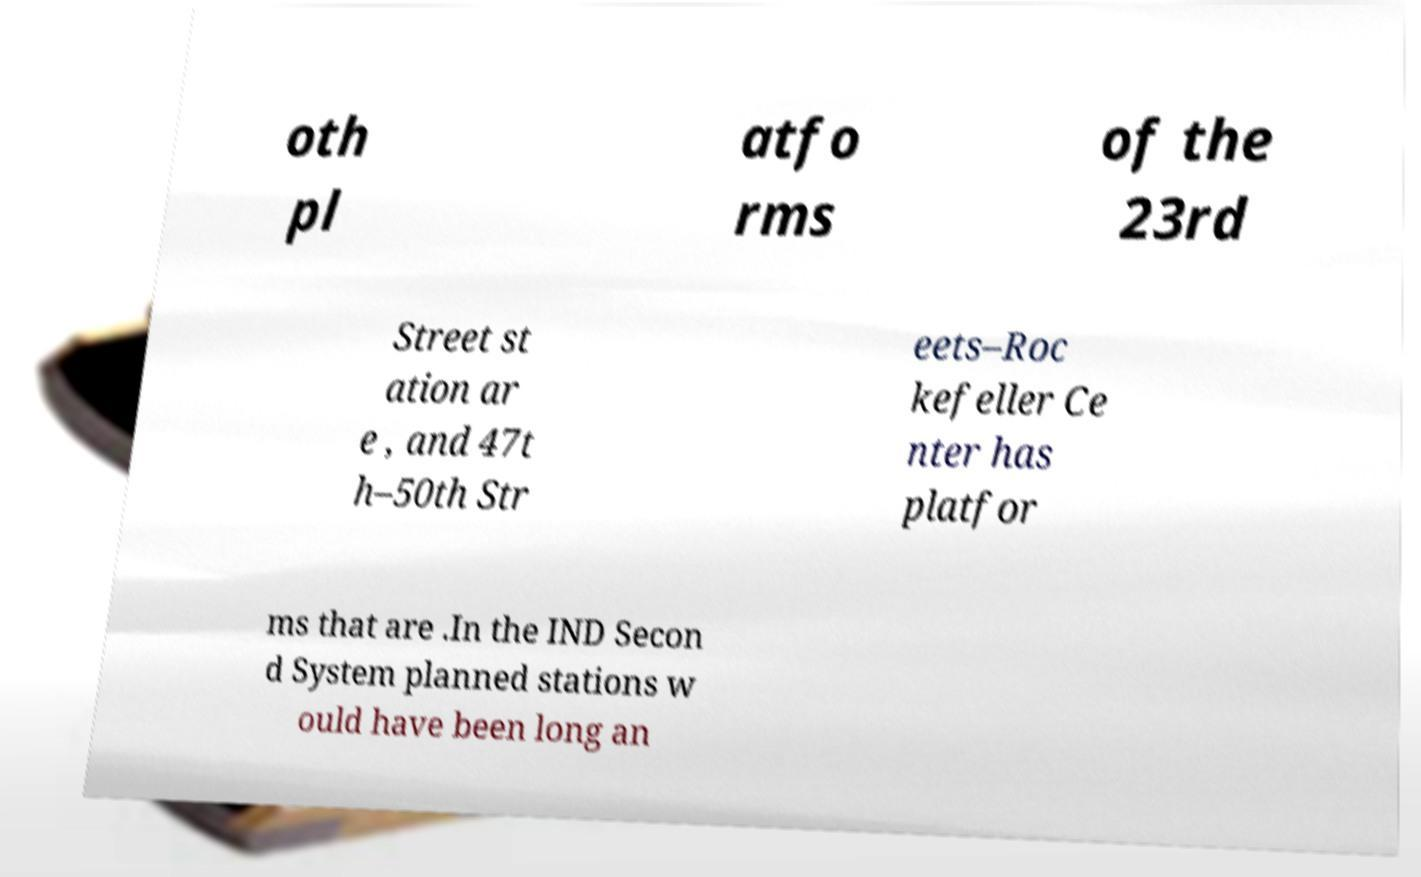What messages or text are displayed in this image? I need them in a readable, typed format. oth pl atfo rms of the 23rd Street st ation ar e , and 47t h–50th Str eets–Roc kefeller Ce nter has platfor ms that are .In the IND Secon d System planned stations w ould have been long an 